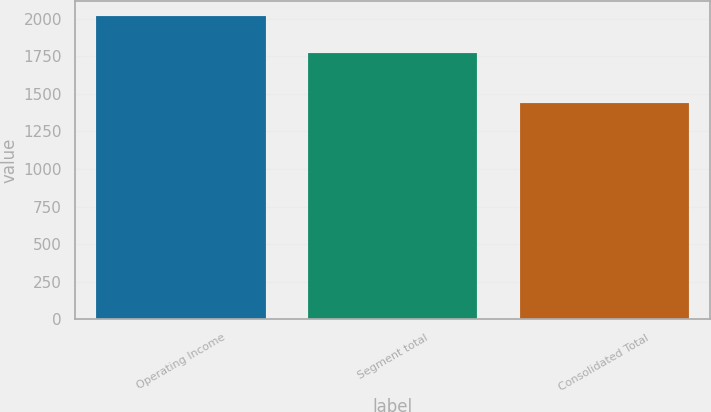Convert chart to OTSL. <chart><loc_0><loc_0><loc_500><loc_500><bar_chart><fcel>Operating Income<fcel>Segment total<fcel>Consolidated Total<nl><fcel>2017<fcel>1773.8<fcel>1440<nl></chart> 